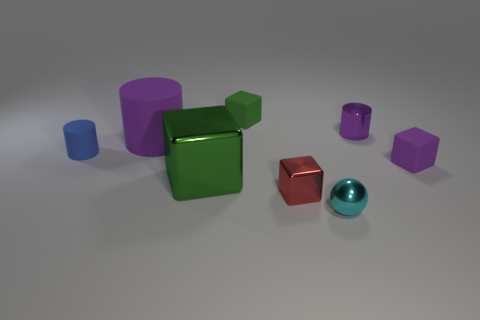Are any of the objects casting a shadow, and if so, which ones? Yes, each object in the image is casting a shadow on the surface due to the lighting in the scene. 